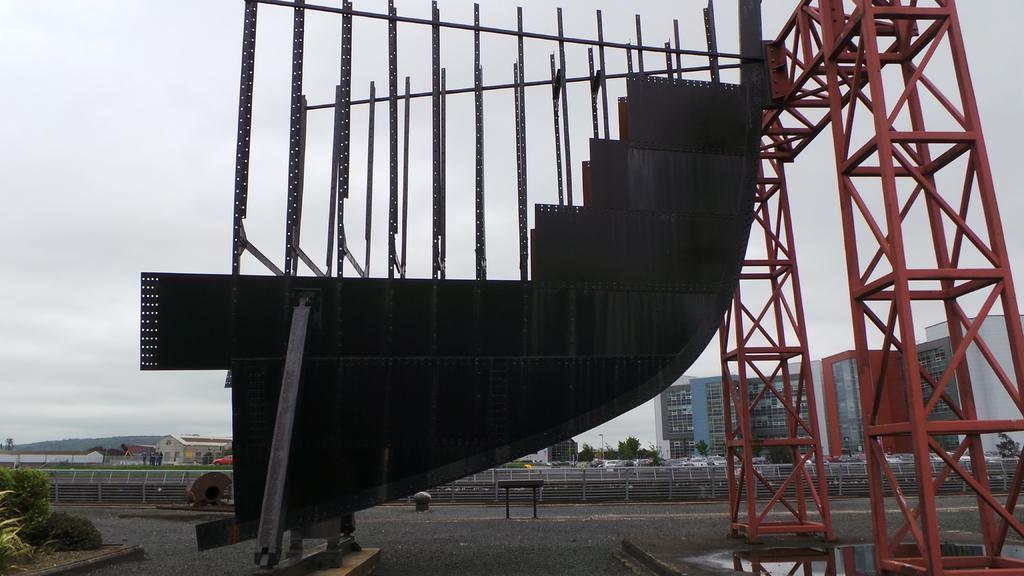How would you summarize this image in a sentence or two? As we can see in the image there are ironic poles, stairs, trees, few people, buildings and at the top there is sky. 